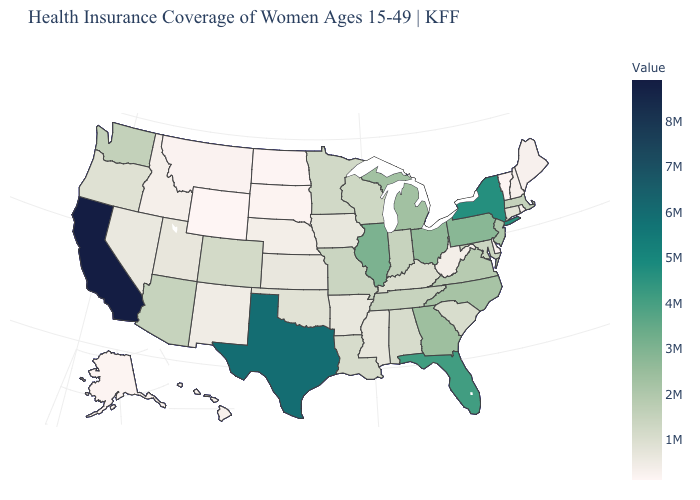Which states hav the highest value in the MidWest?
Answer briefly. Illinois. Does Wyoming have the lowest value in the USA?
Keep it brief. Yes. Among the states that border New York , which have the highest value?
Keep it brief. Pennsylvania. Among the states that border West Virginia , which have the lowest value?
Concise answer only. Kentucky. Which states have the lowest value in the USA?
Be succinct. Wyoming. Does Alaska have the highest value in the West?
Write a very short answer. No. 